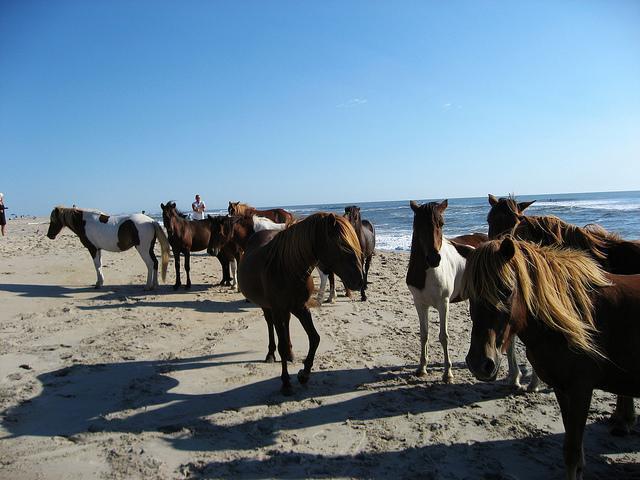How many animals can be seen?
Give a very brief answer. 9. How many horses are in the picture?
Give a very brief answer. 9. How many horses can you see?
Give a very brief answer. 6. 